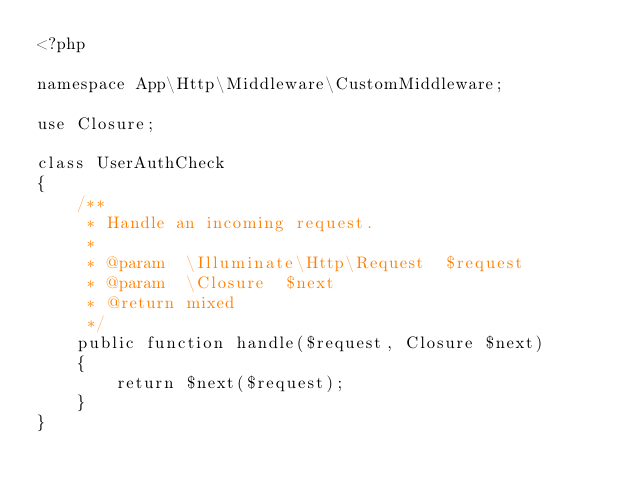Convert code to text. <code><loc_0><loc_0><loc_500><loc_500><_PHP_><?php

namespace App\Http\Middleware\CustomMiddleware;

use Closure;

class UserAuthCheck
{
    /**
     * Handle an incoming request.
     *
     * @param  \Illuminate\Http\Request  $request
     * @param  \Closure  $next
     * @return mixed
     */
    public function handle($request, Closure $next)
    {
        return $next($request);
    }
}
</code> 